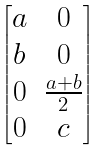<formula> <loc_0><loc_0><loc_500><loc_500>\begin{bmatrix} a & 0 \\ b & 0 \\ 0 & \frac { a + b } { 2 } \\ 0 & c \end{bmatrix}</formula> 